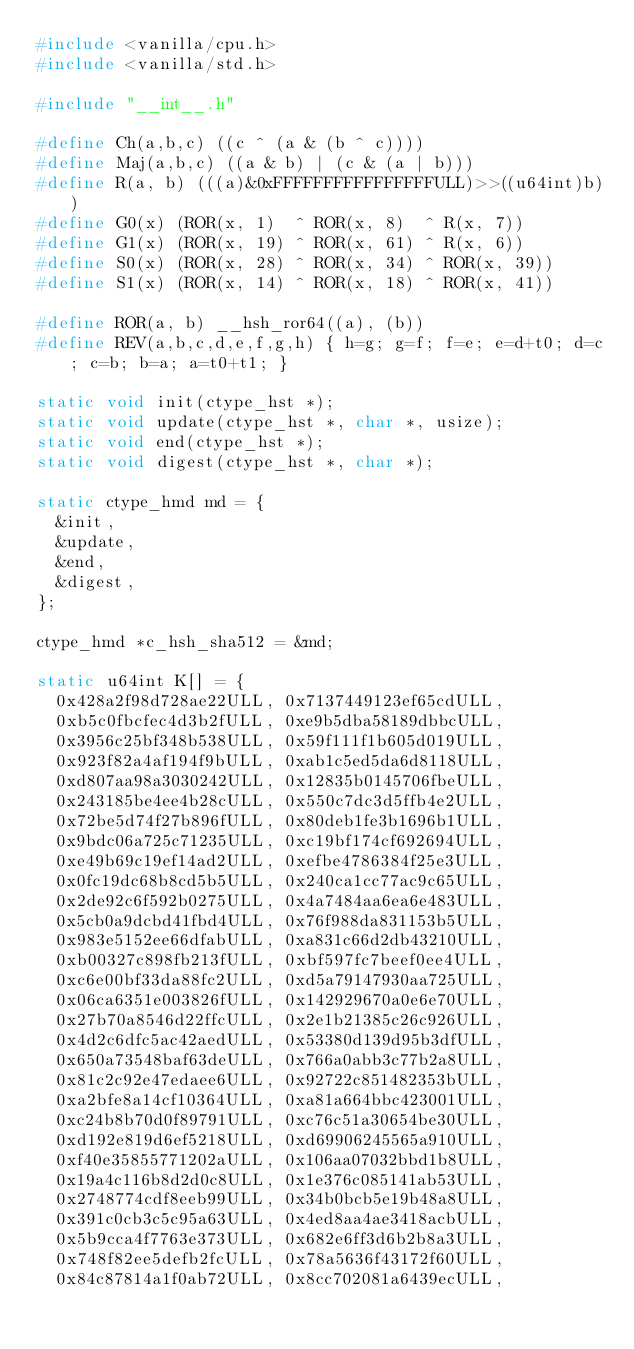<code> <loc_0><loc_0><loc_500><loc_500><_C_>#include <vanilla/cpu.h>
#include <vanilla/std.h>

#include "__int__.h"

#define Ch(a,b,c) ((c ^ (a & (b ^ c))))
#define Maj(a,b,c) ((a & b) | (c & (a | b)))
#define R(a, b) (((a)&0xFFFFFFFFFFFFFFFFULL)>>((u64int)b))
#define G0(x) (ROR(x, 1)  ^ ROR(x, 8)  ^ R(x, 7))
#define G1(x) (ROR(x, 19) ^ ROR(x, 61) ^ R(x, 6))
#define S0(x) (ROR(x, 28) ^ ROR(x, 34) ^ ROR(x, 39))
#define S1(x) (ROR(x, 14) ^ ROR(x, 18) ^ ROR(x, 41))

#define ROR(a, b) __hsh_ror64((a), (b))
#define REV(a,b,c,d,e,f,g,h) { h=g; g=f; f=e; e=d+t0; d=c; c=b; b=a; a=t0+t1; }

static void init(ctype_hst *);
static void update(ctype_hst *, char *, usize);
static void end(ctype_hst *);
static void digest(ctype_hst *, char *);

static ctype_hmd md = {
	&init,
	&update,
	&end,
	&digest,
};

ctype_hmd *c_hsh_sha512 = &md;

static u64int K[] = {
	0x428a2f98d728ae22ULL, 0x7137449123ef65cdULL,
	0xb5c0fbcfec4d3b2fULL, 0xe9b5dba58189dbbcULL,
	0x3956c25bf348b538ULL, 0x59f111f1b605d019ULL,
	0x923f82a4af194f9bULL, 0xab1c5ed5da6d8118ULL,
	0xd807aa98a3030242ULL, 0x12835b0145706fbeULL,
	0x243185be4ee4b28cULL, 0x550c7dc3d5ffb4e2ULL,
	0x72be5d74f27b896fULL, 0x80deb1fe3b1696b1ULL,
	0x9bdc06a725c71235ULL, 0xc19bf174cf692694ULL,
	0xe49b69c19ef14ad2ULL, 0xefbe4786384f25e3ULL,
	0x0fc19dc68b8cd5b5ULL, 0x240ca1cc77ac9c65ULL,
	0x2de92c6f592b0275ULL, 0x4a7484aa6ea6e483ULL,
	0x5cb0a9dcbd41fbd4ULL, 0x76f988da831153b5ULL,
	0x983e5152ee66dfabULL, 0xa831c66d2db43210ULL,
	0xb00327c898fb213fULL, 0xbf597fc7beef0ee4ULL,
	0xc6e00bf33da88fc2ULL, 0xd5a79147930aa725ULL,
	0x06ca6351e003826fULL, 0x142929670a0e6e70ULL,
	0x27b70a8546d22ffcULL, 0x2e1b21385c26c926ULL,
	0x4d2c6dfc5ac42aedULL, 0x53380d139d95b3dfULL,
	0x650a73548baf63deULL, 0x766a0abb3c77b2a8ULL,
	0x81c2c92e47edaee6ULL, 0x92722c851482353bULL,
	0xa2bfe8a14cf10364ULL, 0xa81a664bbc423001ULL,
	0xc24b8b70d0f89791ULL, 0xc76c51a30654be30ULL,
	0xd192e819d6ef5218ULL, 0xd69906245565a910ULL,
	0xf40e35855771202aULL, 0x106aa07032bbd1b8ULL,
	0x19a4c116b8d2d0c8ULL, 0x1e376c085141ab53ULL,
	0x2748774cdf8eeb99ULL, 0x34b0bcb5e19b48a8ULL,
	0x391c0cb3c5c95a63ULL, 0x4ed8aa4ae3418acbULL,
	0x5b9cca4f7763e373ULL, 0x682e6ff3d6b2b8a3ULL,
	0x748f82ee5defb2fcULL, 0x78a5636f43172f60ULL,
	0x84c87814a1f0ab72ULL, 0x8cc702081a6439ecULL,</code> 